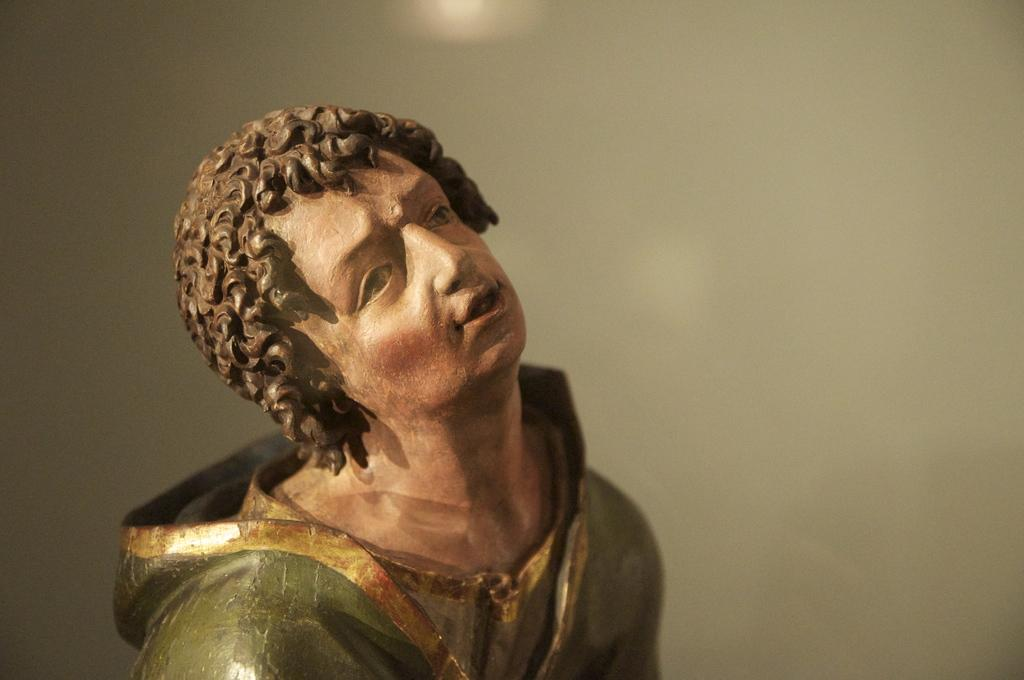What is the main subject of the image? There is a statue of a person in the image. What colors can be seen on the statue? The statue has cream, brown, green, and gold colors. Can you describe the background of the image? The background of the image is blurry. What effect does the expansion have on the trains in the image? There are no trains present in the image, so the concept of expansion does not apply. 